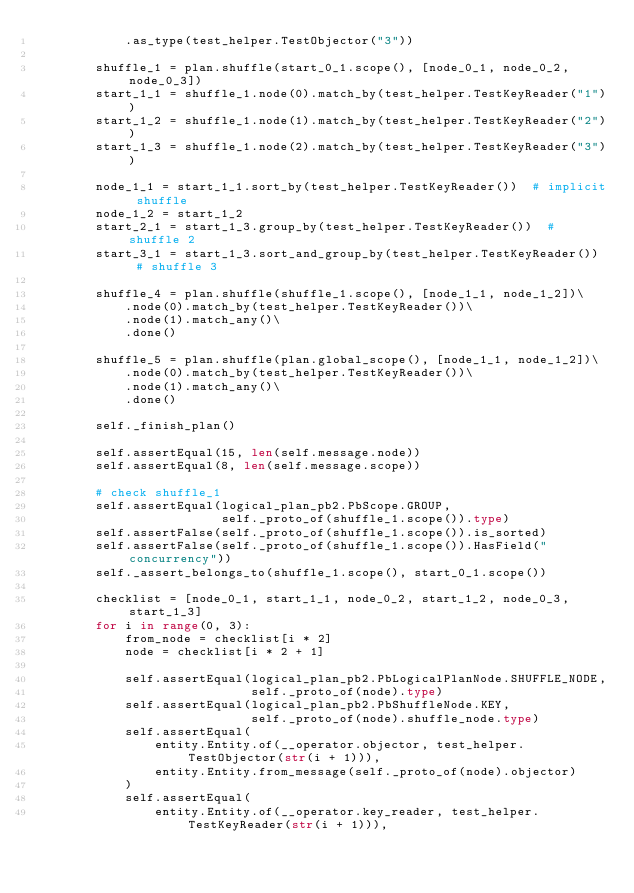Convert code to text. <code><loc_0><loc_0><loc_500><loc_500><_Python_>            .as_type(test_helper.TestObjector("3"))

        shuffle_1 = plan.shuffle(start_0_1.scope(), [node_0_1, node_0_2, node_0_3])
        start_1_1 = shuffle_1.node(0).match_by(test_helper.TestKeyReader("1"))
        start_1_2 = shuffle_1.node(1).match_by(test_helper.TestKeyReader("2"))
        start_1_3 = shuffle_1.node(2).match_by(test_helper.TestKeyReader("3"))

        node_1_1 = start_1_1.sort_by(test_helper.TestKeyReader())  # implicit shuffle
        node_1_2 = start_1_2
        start_2_1 = start_1_3.group_by(test_helper.TestKeyReader())  # shuffle 2
        start_3_1 = start_1_3.sort_and_group_by(test_helper.TestKeyReader())  # shuffle 3

        shuffle_4 = plan.shuffle(shuffle_1.scope(), [node_1_1, node_1_2])\
            .node(0).match_by(test_helper.TestKeyReader())\
            .node(1).match_any()\
            .done()

        shuffle_5 = plan.shuffle(plan.global_scope(), [node_1_1, node_1_2])\
            .node(0).match_by(test_helper.TestKeyReader())\
            .node(1).match_any()\
            .done()

        self._finish_plan()

        self.assertEqual(15, len(self.message.node))
        self.assertEqual(8, len(self.message.scope))

        # check shuffle_1
        self.assertEqual(logical_plan_pb2.PbScope.GROUP,
                         self._proto_of(shuffle_1.scope()).type)
        self.assertFalse(self._proto_of(shuffle_1.scope()).is_sorted)
        self.assertFalse(self._proto_of(shuffle_1.scope()).HasField("concurrency"))
        self._assert_belongs_to(shuffle_1.scope(), start_0_1.scope())

        checklist = [node_0_1, start_1_1, node_0_2, start_1_2, node_0_3, start_1_3]
        for i in range(0, 3):
            from_node = checklist[i * 2]
            node = checklist[i * 2 + 1]

            self.assertEqual(logical_plan_pb2.PbLogicalPlanNode.SHUFFLE_NODE,
                             self._proto_of(node).type)
            self.assertEqual(logical_plan_pb2.PbShuffleNode.KEY,
                             self._proto_of(node).shuffle_node.type)
            self.assertEqual(
                entity.Entity.of(__operator.objector, test_helper.TestObjector(str(i + 1))),
                entity.Entity.from_message(self._proto_of(node).objector)
            )
            self.assertEqual(
                entity.Entity.of(__operator.key_reader, test_helper.TestKeyReader(str(i + 1))),</code> 